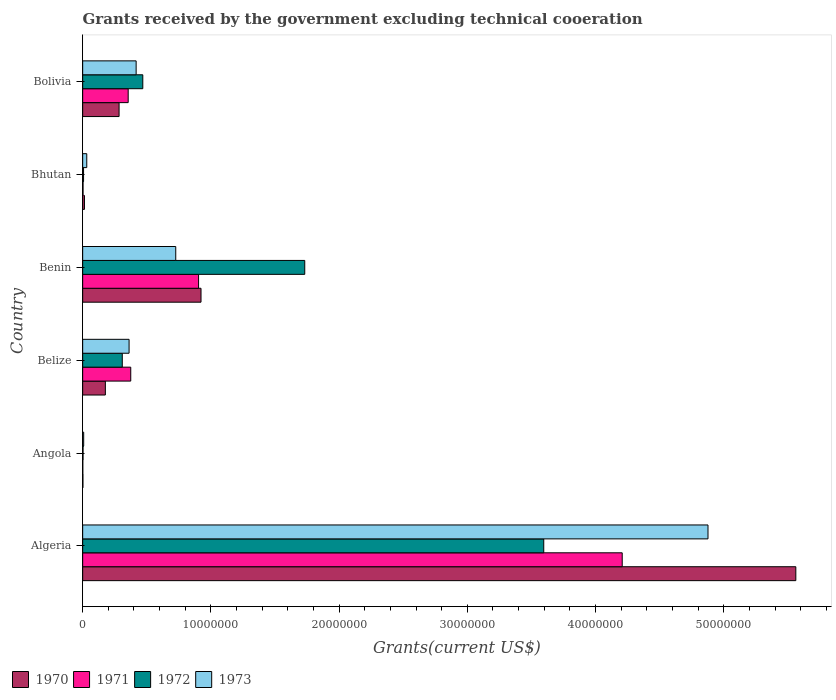How many groups of bars are there?
Your answer should be compact. 6. Are the number of bars per tick equal to the number of legend labels?
Your answer should be very brief. Yes. How many bars are there on the 4th tick from the top?
Provide a short and direct response. 4. What is the label of the 3rd group of bars from the top?
Your response must be concise. Benin. In how many cases, is the number of bars for a given country not equal to the number of legend labels?
Offer a terse response. 0. What is the total grants received by the government in 1972 in Benin?
Provide a short and direct response. 1.73e+07. Across all countries, what is the maximum total grants received by the government in 1971?
Your response must be concise. 4.21e+07. In which country was the total grants received by the government in 1973 maximum?
Provide a short and direct response. Algeria. In which country was the total grants received by the government in 1971 minimum?
Provide a short and direct response. Angola. What is the total total grants received by the government in 1971 in the graph?
Offer a very short reply. 5.85e+07. What is the difference between the total grants received by the government in 1972 in Algeria and that in Angola?
Ensure brevity in your answer.  3.59e+07. What is the average total grants received by the government in 1970 per country?
Your response must be concise. 1.16e+07. What is the difference between the total grants received by the government in 1973 and total grants received by the government in 1971 in Bolivia?
Keep it short and to the point. 6.20e+05. In how many countries, is the total grants received by the government in 1972 greater than 28000000 US$?
Provide a succinct answer. 1. What is the ratio of the total grants received by the government in 1972 in Angola to that in Bhutan?
Offer a terse response. 0.43. Is the total grants received by the government in 1972 in Algeria less than that in Belize?
Your answer should be very brief. No. What is the difference between the highest and the second highest total grants received by the government in 1971?
Ensure brevity in your answer.  3.30e+07. What is the difference between the highest and the lowest total grants received by the government in 1972?
Keep it short and to the point. 3.59e+07. In how many countries, is the total grants received by the government in 1973 greater than the average total grants received by the government in 1973 taken over all countries?
Provide a short and direct response. 1. Is the sum of the total grants received by the government in 1972 in Benin and Bhutan greater than the maximum total grants received by the government in 1971 across all countries?
Give a very brief answer. No. Is it the case that in every country, the sum of the total grants received by the government in 1970 and total grants received by the government in 1971 is greater than the sum of total grants received by the government in 1972 and total grants received by the government in 1973?
Provide a succinct answer. No. What does the 4th bar from the top in Algeria represents?
Your answer should be very brief. 1970. What does the 4th bar from the bottom in Algeria represents?
Make the answer very short. 1973. Is it the case that in every country, the sum of the total grants received by the government in 1971 and total grants received by the government in 1970 is greater than the total grants received by the government in 1973?
Provide a succinct answer. No. How many countries are there in the graph?
Provide a short and direct response. 6. How many legend labels are there?
Give a very brief answer. 4. What is the title of the graph?
Offer a very short reply. Grants received by the government excluding technical cooeration. What is the label or title of the X-axis?
Keep it short and to the point. Grants(current US$). What is the label or title of the Y-axis?
Offer a terse response. Country. What is the Grants(current US$) in 1970 in Algeria?
Ensure brevity in your answer.  5.56e+07. What is the Grants(current US$) of 1971 in Algeria?
Your response must be concise. 4.21e+07. What is the Grants(current US$) in 1972 in Algeria?
Your answer should be very brief. 3.60e+07. What is the Grants(current US$) in 1973 in Algeria?
Offer a very short reply. 4.88e+07. What is the Grants(current US$) in 1970 in Angola?
Your response must be concise. 2.00e+04. What is the Grants(current US$) in 1973 in Angola?
Give a very brief answer. 8.00e+04. What is the Grants(current US$) of 1970 in Belize?
Give a very brief answer. 1.77e+06. What is the Grants(current US$) of 1971 in Belize?
Offer a terse response. 3.75e+06. What is the Grants(current US$) in 1972 in Belize?
Keep it short and to the point. 3.09e+06. What is the Grants(current US$) in 1973 in Belize?
Offer a terse response. 3.62e+06. What is the Grants(current US$) of 1970 in Benin?
Provide a short and direct response. 9.23e+06. What is the Grants(current US$) of 1971 in Benin?
Your response must be concise. 9.04e+06. What is the Grants(current US$) in 1972 in Benin?
Provide a short and direct response. 1.73e+07. What is the Grants(current US$) of 1973 in Benin?
Your answer should be compact. 7.26e+06. What is the Grants(current US$) in 1970 in Bolivia?
Provide a short and direct response. 2.84e+06. What is the Grants(current US$) of 1971 in Bolivia?
Provide a short and direct response. 3.55e+06. What is the Grants(current US$) in 1972 in Bolivia?
Provide a succinct answer. 4.69e+06. What is the Grants(current US$) of 1973 in Bolivia?
Ensure brevity in your answer.  4.17e+06. Across all countries, what is the maximum Grants(current US$) of 1970?
Make the answer very short. 5.56e+07. Across all countries, what is the maximum Grants(current US$) of 1971?
Your answer should be very brief. 4.21e+07. Across all countries, what is the maximum Grants(current US$) of 1972?
Your answer should be compact. 3.60e+07. Across all countries, what is the maximum Grants(current US$) of 1973?
Provide a succinct answer. 4.88e+07. Across all countries, what is the minimum Grants(current US$) of 1970?
Keep it short and to the point. 2.00e+04. What is the total Grants(current US$) in 1970 in the graph?
Your answer should be very brief. 6.96e+07. What is the total Grants(current US$) of 1971 in the graph?
Ensure brevity in your answer.  5.85e+07. What is the total Grants(current US$) of 1972 in the graph?
Provide a short and direct response. 6.12e+07. What is the total Grants(current US$) in 1973 in the graph?
Provide a short and direct response. 6.42e+07. What is the difference between the Grants(current US$) of 1970 in Algeria and that in Angola?
Provide a succinct answer. 5.56e+07. What is the difference between the Grants(current US$) of 1971 in Algeria and that in Angola?
Offer a terse response. 4.21e+07. What is the difference between the Grants(current US$) of 1972 in Algeria and that in Angola?
Ensure brevity in your answer.  3.59e+07. What is the difference between the Grants(current US$) of 1973 in Algeria and that in Angola?
Offer a very short reply. 4.87e+07. What is the difference between the Grants(current US$) in 1970 in Algeria and that in Belize?
Provide a succinct answer. 5.38e+07. What is the difference between the Grants(current US$) of 1971 in Algeria and that in Belize?
Provide a succinct answer. 3.83e+07. What is the difference between the Grants(current US$) in 1972 in Algeria and that in Belize?
Ensure brevity in your answer.  3.29e+07. What is the difference between the Grants(current US$) of 1973 in Algeria and that in Belize?
Keep it short and to the point. 4.52e+07. What is the difference between the Grants(current US$) of 1970 in Algeria and that in Benin?
Keep it short and to the point. 4.64e+07. What is the difference between the Grants(current US$) of 1971 in Algeria and that in Benin?
Your answer should be very brief. 3.30e+07. What is the difference between the Grants(current US$) in 1972 in Algeria and that in Benin?
Make the answer very short. 1.86e+07. What is the difference between the Grants(current US$) of 1973 in Algeria and that in Benin?
Ensure brevity in your answer.  4.15e+07. What is the difference between the Grants(current US$) of 1970 in Algeria and that in Bhutan?
Give a very brief answer. 5.55e+07. What is the difference between the Grants(current US$) in 1971 in Algeria and that in Bhutan?
Provide a short and direct response. 4.20e+07. What is the difference between the Grants(current US$) of 1972 in Algeria and that in Bhutan?
Keep it short and to the point. 3.59e+07. What is the difference between the Grants(current US$) in 1973 in Algeria and that in Bhutan?
Your response must be concise. 4.84e+07. What is the difference between the Grants(current US$) of 1970 in Algeria and that in Bolivia?
Provide a short and direct response. 5.28e+07. What is the difference between the Grants(current US$) of 1971 in Algeria and that in Bolivia?
Provide a succinct answer. 3.85e+07. What is the difference between the Grants(current US$) in 1972 in Algeria and that in Bolivia?
Your answer should be very brief. 3.13e+07. What is the difference between the Grants(current US$) in 1973 in Algeria and that in Bolivia?
Keep it short and to the point. 4.46e+07. What is the difference between the Grants(current US$) of 1970 in Angola and that in Belize?
Offer a terse response. -1.75e+06. What is the difference between the Grants(current US$) of 1971 in Angola and that in Belize?
Provide a short and direct response. -3.74e+06. What is the difference between the Grants(current US$) in 1972 in Angola and that in Belize?
Make the answer very short. -3.06e+06. What is the difference between the Grants(current US$) in 1973 in Angola and that in Belize?
Offer a terse response. -3.54e+06. What is the difference between the Grants(current US$) of 1970 in Angola and that in Benin?
Your answer should be compact. -9.21e+06. What is the difference between the Grants(current US$) of 1971 in Angola and that in Benin?
Keep it short and to the point. -9.03e+06. What is the difference between the Grants(current US$) in 1972 in Angola and that in Benin?
Keep it short and to the point. -1.73e+07. What is the difference between the Grants(current US$) of 1973 in Angola and that in Benin?
Offer a very short reply. -7.18e+06. What is the difference between the Grants(current US$) of 1971 in Angola and that in Bhutan?
Your response must be concise. -2.00e+04. What is the difference between the Grants(current US$) in 1973 in Angola and that in Bhutan?
Offer a very short reply. -2.40e+05. What is the difference between the Grants(current US$) of 1970 in Angola and that in Bolivia?
Give a very brief answer. -2.82e+06. What is the difference between the Grants(current US$) of 1971 in Angola and that in Bolivia?
Offer a terse response. -3.54e+06. What is the difference between the Grants(current US$) in 1972 in Angola and that in Bolivia?
Keep it short and to the point. -4.66e+06. What is the difference between the Grants(current US$) in 1973 in Angola and that in Bolivia?
Provide a succinct answer. -4.09e+06. What is the difference between the Grants(current US$) of 1970 in Belize and that in Benin?
Ensure brevity in your answer.  -7.46e+06. What is the difference between the Grants(current US$) of 1971 in Belize and that in Benin?
Your response must be concise. -5.29e+06. What is the difference between the Grants(current US$) in 1972 in Belize and that in Benin?
Ensure brevity in your answer.  -1.42e+07. What is the difference between the Grants(current US$) in 1973 in Belize and that in Benin?
Provide a short and direct response. -3.64e+06. What is the difference between the Grants(current US$) of 1970 in Belize and that in Bhutan?
Give a very brief answer. 1.63e+06. What is the difference between the Grants(current US$) of 1971 in Belize and that in Bhutan?
Make the answer very short. 3.72e+06. What is the difference between the Grants(current US$) in 1972 in Belize and that in Bhutan?
Provide a short and direct response. 3.02e+06. What is the difference between the Grants(current US$) in 1973 in Belize and that in Bhutan?
Provide a short and direct response. 3.30e+06. What is the difference between the Grants(current US$) of 1970 in Belize and that in Bolivia?
Keep it short and to the point. -1.07e+06. What is the difference between the Grants(current US$) of 1972 in Belize and that in Bolivia?
Offer a terse response. -1.60e+06. What is the difference between the Grants(current US$) of 1973 in Belize and that in Bolivia?
Make the answer very short. -5.50e+05. What is the difference between the Grants(current US$) in 1970 in Benin and that in Bhutan?
Offer a terse response. 9.09e+06. What is the difference between the Grants(current US$) in 1971 in Benin and that in Bhutan?
Give a very brief answer. 9.01e+06. What is the difference between the Grants(current US$) of 1972 in Benin and that in Bhutan?
Ensure brevity in your answer.  1.72e+07. What is the difference between the Grants(current US$) of 1973 in Benin and that in Bhutan?
Your answer should be very brief. 6.94e+06. What is the difference between the Grants(current US$) of 1970 in Benin and that in Bolivia?
Provide a short and direct response. 6.39e+06. What is the difference between the Grants(current US$) of 1971 in Benin and that in Bolivia?
Provide a succinct answer. 5.49e+06. What is the difference between the Grants(current US$) in 1972 in Benin and that in Bolivia?
Offer a terse response. 1.26e+07. What is the difference between the Grants(current US$) of 1973 in Benin and that in Bolivia?
Provide a short and direct response. 3.09e+06. What is the difference between the Grants(current US$) of 1970 in Bhutan and that in Bolivia?
Your answer should be very brief. -2.70e+06. What is the difference between the Grants(current US$) in 1971 in Bhutan and that in Bolivia?
Ensure brevity in your answer.  -3.52e+06. What is the difference between the Grants(current US$) in 1972 in Bhutan and that in Bolivia?
Give a very brief answer. -4.62e+06. What is the difference between the Grants(current US$) of 1973 in Bhutan and that in Bolivia?
Provide a succinct answer. -3.85e+06. What is the difference between the Grants(current US$) of 1970 in Algeria and the Grants(current US$) of 1971 in Angola?
Provide a short and direct response. 5.56e+07. What is the difference between the Grants(current US$) in 1970 in Algeria and the Grants(current US$) in 1972 in Angola?
Your answer should be very brief. 5.56e+07. What is the difference between the Grants(current US$) of 1970 in Algeria and the Grants(current US$) of 1973 in Angola?
Offer a terse response. 5.55e+07. What is the difference between the Grants(current US$) in 1971 in Algeria and the Grants(current US$) in 1972 in Angola?
Provide a short and direct response. 4.20e+07. What is the difference between the Grants(current US$) in 1971 in Algeria and the Grants(current US$) in 1973 in Angola?
Give a very brief answer. 4.20e+07. What is the difference between the Grants(current US$) in 1972 in Algeria and the Grants(current US$) in 1973 in Angola?
Provide a short and direct response. 3.59e+07. What is the difference between the Grants(current US$) in 1970 in Algeria and the Grants(current US$) in 1971 in Belize?
Offer a very short reply. 5.19e+07. What is the difference between the Grants(current US$) of 1970 in Algeria and the Grants(current US$) of 1972 in Belize?
Keep it short and to the point. 5.25e+07. What is the difference between the Grants(current US$) in 1970 in Algeria and the Grants(current US$) in 1973 in Belize?
Keep it short and to the point. 5.20e+07. What is the difference between the Grants(current US$) of 1971 in Algeria and the Grants(current US$) of 1972 in Belize?
Ensure brevity in your answer.  3.90e+07. What is the difference between the Grants(current US$) in 1971 in Algeria and the Grants(current US$) in 1973 in Belize?
Your answer should be very brief. 3.85e+07. What is the difference between the Grants(current US$) of 1972 in Algeria and the Grants(current US$) of 1973 in Belize?
Keep it short and to the point. 3.23e+07. What is the difference between the Grants(current US$) in 1970 in Algeria and the Grants(current US$) in 1971 in Benin?
Ensure brevity in your answer.  4.66e+07. What is the difference between the Grants(current US$) of 1970 in Algeria and the Grants(current US$) of 1972 in Benin?
Keep it short and to the point. 3.83e+07. What is the difference between the Grants(current US$) of 1970 in Algeria and the Grants(current US$) of 1973 in Benin?
Provide a short and direct response. 4.84e+07. What is the difference between the Grants(current US$) in 1971 in Algeria and the Grants(current US$) in 1972 in Benin?
Make the answer very short. 2.48e+07. What is the difference between the Grants(current US$) of 1971 in Algeria and the Grants(current US$) of 1973 in Benin?
Ensure brevity in your answer.  3.48e+07. What is the difference between the Grants(current US$) in 1972 in Algeria and the Grants(current US$) in 1973 in Benin?
Give a very brief answer. 2.87e+07. What is the difference between the Grants(current US$) of 1970 in Algeria and the Grants(current US$) of 1971 in Bhutan?
Your answer should be very brief. 5.56e+07. What is the difference between the Grants(current US$) of 1970 in Algeria and the Grants(current US$) of 1972 in Bhutan?
Your answer should be very brief. 5.56e+07. What is the difference between the Grants(current US$) in 1970 in Algeria and the Grants(current US$) in 1973 in Bhutan?
Make the answer very short. 5.53e+07. What is the difference between the Grants(current US$) in 1971 in Algeria and the Grants(current US$) in 1972 in Bhutan?
Provide a short and direct response. 4.20e+07. What is the difference between the Grants(current US$) in 1971 in Algeria and the Grants(current US$) in 1973 in Bhutan?
Offer a very short reply. 4.18e+07. What is the difference between the Grants(current US$) of 1972 in Algeria and the Grants(current US$) of 1973 in Bhutan?
Offer a very short reply. 3.56e+07. What is the difference between the Grants(current US$) of 1970 in Algeria and the Grants(current US$) of 1971 in Bolivia?
Make the answer very short. 5.21e+07. What is the difference between the Grants(current US$) in 1970 in Algeria and the Grants(current US$) in 1972 in Bolivia?
Your response must be concise. 5.09e+07. What is the difference between the Grants(current US$) of 1970 in Algeria and the Grants(current US$) of 1973 in Bolivia?
Provide a succinct answer. 5.14e+07. What is the difference between the Grants(current US$) in 1971 in Algeria and the Grants(current US$) in 1972 in Bolivia?
Your answer should be compact. 3.74e+07. What is the difference between the Grants(current US$) of 1971 in Algeria and the Grants(current US$) of 1973 in Bolivia?
Your answer should be compact. 3.79e+07. What is the difference between the Grants(current US$) of 1972 in Algeria and the Grants(current US$) of 1973 in Bolivia?
Make the answer very short. 3.18e+07. What is the difference between the Grants(current US$) in 1970 in Angola and the Grants(current US$) in 1971 in Belize?
Make the answer very short. -3.73e+06. What is the difference between the Grants(current US$) of 1970 in Angola and the Grants(current US$) of 1972 in Belize?
Offer a very short reply. -3.07e+06. What is the difference between the Grants(current US$) in 1970 in Angola and the Grants(current US$) in 1973 in Belize?
Provide a short and direct response. -3.60e+06. What is the difference between the Grants(current US$) of 1971 in Angola and the Grants(current US$) of 1972 in Belize?
Your answer should be very brief. -3.08e+06. What is the difference between the Grants(current US$) in 1971 in Angola and the Grants(current US$) in 1973 in Belize?
Your answer should be very brief. -3.61e+06. What is the difference between the Grants(current US$) of 1972 in Angola and the Grants(current US$) of 1973 in Belize?
Provide a succinct answer. -3.59e+06. What is the difference between the Grants(current US$) in 1970 in Angola and the Grants(current US$) in 1971 in Benin?
Ensure brevity in your answer.  -9.02e+06. What is the difference between the Grants(current US$) of 1970 in Angola and the Grants(current US$) of 1972 in Benin?
Your response must be concise. -1.73e+07. What is the difference between the Grants(current US$) of 1970 in Angola and the Grants(current US$) of 1973 in Benin?
Provide a short and direct response. -7.24e+06. What is the difference between the Grants(current US$) in 1971 in Angola and the Grants(current US$) in 1972 in Benin?
Ensure brevity in your answer.  -1.73e+07. What is the difference between the Grants(current US$) of 1971 in Angola and the Grants(current US$) of 1973 in Benin?
Ensure brevity in your answer.  -7.25e+06. What is the difference between the Grants(current US$) in 1972 in Angola and the Grants(current US$) in 1973 in Benin?
Give a very brief answer. -7.23e+06. What is the difference between the Grants(current US$) in 1970 in Angola and the Grants(current US$) in 1973 in Bhutan?
Your answer should be compact. -3.00e+05. What is the difference between the Grants(current US$) of 1971 in Angola and the Grants(current US$) of 1973 in Bhutan?
Make the answer very short. -3.10e+05. What is the difference between the Grants(current US$) in 1972 in Angola and the Grants(current US$) in 1973 in Bhutan?
Your answer should be compact. -2.90e+05. What is the difference between the Grants(current US$) of 1970 in Angola and the Grants(current US$) of 1971 in Bolivia?
Provide a succinct answer. -3.53e+06. What is the difference between the Grants(current US$) in 1970 in Angola and the Grants(current US$) in 1972 in Bolivia?
Your answer should be compact. -4.67e+06. What is the difference between the Grants(current US$) of 1970 in Angola and the Grants(current US$) of 1973 in Bolivia?
Provide a short and direct response. -4.15e+06. What is the difference between the Grants(current US$) in 1971 in Angola and the Grants(current US$) in 1972 in Bolivia?
Keep it short and to the point. -4.68e+06. What is the difference between the Grants(current US$) of 1971 in Angola and the Grants(current US$) of 1973 in Bolivia?
Make the answer very short. -4.16e+06. What is the difference between the Grants(current US$) of 1972 in Angola and the Grants(current US$) of 1973 in Bolivia?
Ensure brevity in your answer.  -4.14e+06. What is the difference between the Grants(current US$) in 1970 in Belize and the Grants(current US$) in 1971 in Benin?
Ensure brevity in your answer.  -7.27e+06. What is the difference between the Grants(current US$) of 1970 in Belize and the Grants(current US$) of 1972 in Benin?
Offer a very short reply. -1.56e+07. What is the difference between the Grants(current US$) in 1970 in Belize and the Grants(current US$) in 1973 in Benin?
Offer a terse response. -5.49e+06. What is the difference between the Grants(current US$) of 1971 in Belize and the Grants(current US$) of 1972 in Benin?
Provide a short and direct response. -1.36e+07. What is the difference between the Grants(current US$) of 1971 in Belize and the Grants(current US$) of 1973 in Benin?
Make the answer very short. -3.51e+06. What is the difference between the Grants(current US$) of 1972 in Belize and the Grants(current US$) of 1973 in Benin?
Give a very brief answer. -4.17e+06. What is the difference between the Grants(current US$) in 1970 in Belize and the Grants(current US$) in 1971 in Bhutan?
Ensure brevity in your answer.  1.74e+06. What is the difference between the Grants(current US$) of 1970 in Belize and the Grants(current US$) of 1972 in Bhutan?
Your answer should be compact. 1.70e+06. What is the difference between the Grants(current US$) of 1970 in Belize and the Grants(current US$) of 1973 in Bhutan?
Offer a terse response. 1.45e+06. What is the difference between the Grants(current US$) of 1971 in Belize and the Grants(current US$) of 1972 in Bhutan?
Keep it short and to the point. 3.68e+06. What is the difference between the Grants(current US$) in 1971 in Belize and the Grants(current US$) in 1973 in Bhutan?
Make the answer very short. 3.43e+06. What is the difference between the Grants(current US$) in 1972 in Belize and the Grants(current US$) in 1973 in Bhutan?
Your answer should be very brief. 2.77e+06. What is the difference between the Grants(current US$) of 1970 in Belize and the Grants(current US$) of 1971 in Bolivia?
Your answer should be compact. -1.78e+06. What is the difference between the Grants(current US$) in 1970 in Belize and the Grants(current US$) in 1972 in Bolivia?
Give a very brief answer. -2.92e+06. What is the difference between the Grants(current US$) in 1970 in Belize and the Grants(current US$) in 1973 in Bolivia?
Provide a succinct answer. -2.40e+06. What is the difference between the Grants(current US$) of 1971 in Belize and the Grants(current US$) of 1972 in Bolivia?
Offer a terse response. -9.40e+05. What is the difference between the Grants(current US$) in 1971 in Belize and the Grants(current US$) in 1973 in Bolivia?
Provide a short and direct response. -4.20e+05. What is the difference between the Grants(current US$) of 1972 in Belize and the Grants(current US$) of 1973 in Bolivia?
Ensure brevity in your answer.  -1.08e+06. What is the difference between the Grants(current US$) of 1970 in Benin and the Grants(current US$) of 1971 in Bhutan?
Your answer should be very brief. 9.20e+06. What is the difference between the Grants(current US$) of 1970 in Benin and the Grants(current US$) of 1972 in Bhutan?
Your response must be concise. 9.16e+06. What is the difference between the Grants(current US$) in 1970 in Benin and the Grants(current US$) in 1973 in Bhutan?
Keep it short and to the point. 8.91e+06. What is the difference between the Grants(current US$) in 1971 in Benin and the Grants(current US$) in 1972 in Bhutan?
Your response must be concise. 8.97e+06. What is the difference between the Grants(current US$) in 1971 in Benin and the Grants(current US$) in 1973 in Bhutan?
Provide a short and direct response. 8.72e+06. What is the difference between the Grants(current US$) of 1972 in Benin and the Grants(current US$) of 1973 in Bhutan?
Provide a succinct answer. 1.70e+07. What is the difference between the Grants(current US$) of 1970 in Benin and the Grants(current US$) of 1971 in Bolivia?
Provide a succinct answer. 5.68e+06. What is the difference between the Grants(current US$) in 1970 in Benin and the Grants(current US$) in 1972 in Bolivia?
Give a very brief answer. 4.54e+06. What is the difference between the Grants(current US$) of 1970 in Benin and the Grants(current US$) of 1973 in Bolivia?
Offer a terse response. 5.06e+06. What is the difference between the Grants(current US$) of 1971 in Benin and the Grants(current US$) of 1972 in Bolivia?
Ensure brevity in your answer.  4.35e+06. What is the difference between the Grants(current US$) of 1971 in Benin and the Grants(current US$) of 1973 in Bolivia?
Your answer should be very brief. 4.87e+06. What is the difference between the Grants(current US$) of 1972 in Benin and the Grants(current US$) of 1973 in Bolivia?
Offer a terse response. 1.32e+07. What is the difference between the Grants(current US$) in 1970 in Bhutan and the Grants(current US$) in 1971 in Bolivia?
Your answer should be compact. -3.41e+06. What is the difference between the Grants(current US$) of 1970 in Bhutan and the Grants(current US$) of 1972 in Bolivia?
Give a very brief answer. -4.55e+06. What is the difference between the Grants(current US$) of 1970 in Bhutan and the Grants(current US$) of 1973 in Bolivia?
Your answer should be very brief. -4.03e+06. What is the difference between the Grants(current US$) in 1971 in Bhutan and the Grants(current US$) in 1972 in Bolivia?
Your response must be concise. -4.66e+06. What is the difference between the Grants(current US$) of 1971 in Bhutan and the Grants(current US$) of 1973 in Bolivia?
Your answer should be very brief. -4.14e+06. What is the difference between the Grants(current US$) in 1972 in Bhutan and the Grants(current US$) in 1973 in Bolivia?
Make the answer very short. -4.10e+06. What is the average Grants(current US$) of 1970 per country?
Ensure brevity in your answer.  1.16e+07. What is the average Grants(current US$) of 1971 per country?
Make the answer very short. 9.74e+06. What is the average Grants(current US$) of 1972 per country?
Make the answer very short. 1.02e+07. What is the average Grants(current US$) in 1973 per country?
Offer a very short reply. 1.07e+07. What is the difference between the Grants(current US$) of 1970 and Grants(current US$) of 1971 in Algeria?
Offer a very short reply. 1.35e+07. What is the difference between the Grants(current US$) in 1970 and Grants(current US$) in 1972 in Algeria?
Provide a short and direct response. 1.97e+07. What is the difference between the Grants(current US$) in 1970 and Grants(current US$) in 1973 in Algeria?
Your answer should be compact. 6.85e+06. What is the difference between the Grants(current US$) in 1971 and Grants(current US$) in 1972 in Algeria?
Your response must be concise. 6.12e+06. What is the difference between the Grants(current US$) of 1971 and Grants(current US$) of 1973 in Algeria?
Your response must be concise. -6.69e+06. What is the difference between the Grants(current US$) of 1972 and Grants(current US$) of 1973 in Algeria?
Give a very brief answer. -1.28e+07. What is the difference between the Grants(current US$) in 1970 and Grants(current US$) in 1971 in Angola?
Your answer should be compact. 10000. What is the difference between the Grants(current US$) in 1970 and Grants(current US$) in 1973 in Angola?
Make the answer very short. -6.00e+04. What is the difference between the Grants(current US$) of 1971 and Grants(current US$) of 1972 in Angola?
Provide a short and direct response. -2.00e+04. What is the difference between the Grants(current US$) in 1972 and Grants(current US$) in 1973 in Angola?
Keep it short and to the point. -5.00e+04. What is the difference between the Grants(current US$) of 1970 and Grants(current US$) of 1971 in Belize?
Ensure brevity in your answer.  -1.98e+06. What is the difference between the Grants(current US$) in 1970 and Grants(current US$) in 1972 in Belize?
Ensure brevity in your answer.  -1.32e+06. What is the difference between the Grants(current US$) of 1970 and Grants(current US$) of 1973 in Belize?
Your answer should be compact. -1.85e+06. What is the difference between the Grants(current US$) in 1972 and Grants(current US$) in 1973 in Belize?
Give a very brief answer. -5.30e+05. What is the difference between the Grants(current US$) of 1970 and Grants(current US$) of 1972 in Benin?
Keep it short and to the point. -8.09e+06. What is the difference between the Grants(current US$) in 1970 and Grants(current US$) in 1973 in Benin?
Give a very brief answer. 1.97e+06. What is the difference between the Grants(current US$) in 1971 and Grants(current US$) in 1972 in Benin?
Provide a short and direct response. -8.28e+06. What is the difference between the Grants(current US$) in 1971 and Grants(current US$) in 1973 in Benin?
Offer a very short reply. 1.78e+06. What is the difference between the Grants(current US$) of 1972 and Grants(current US$) of 1973 in Benin?
Offer a terse response. 1.01e+07. What is the difference between the Grants(current US$) in 1970 and Grants(current US$) in 1971 in Bhutan?
Your answer should be compact. 1.10e+05. What is the difference between the Grants(current US$) of 1971 and Grants(current US$) of 1973 in Bhutan?
Your response must be concise. -2.90e+05. What is the difference between the Grants(current US$) in 1972 and Grants(current US$) in 1973 in Bhutan?
Offer a terse response. -2.50e+05. What is the difference between the Grants(current US$) in 1970 and Grants(current US$) in 1971 in Bolivia?
Provide a short and direct response. -7.10e+05. What is the difference between the Grants(current US$) in 1970 and Grants(current US$) in 1972 in Bolivia?
Give a very brief answer. -1.85e+06. What is the difference between the Grants(current US$) of 1970 and Grants(current US$) of 1973 in Bolivia?
Give a very brief answer. -1.33e+06. What is the difference between the Grants(current US$) of 1971 and Grants(current US$) of 1972 in Bolivia?
Provide a short and direct response. -1.14e+06. What is the difference between the Grants(current US$) of 1971 and Grants(current US$) of 1973 in Bolivia?
Give a very brief answer. -6.20e+05. What is the difference between the Grants(current US$) in 1972 and Grants(current US$) in 1973 in Bolivia?
Your answer should be very brief. 5.20e+05. What is the ratio of the Grants(current US$) of 1970 in Algeria to that in Angola?
Ensure brevity in your answer.  2781. What is the ratio of the Grants(current US$) of 1971 in Algeria to that in Angola?
Give a very brief answer. 4208. What is the ratio of the Grants(current US$) in 1972 in Algeria to that in Angola?
Give a very brief answer. 1198.67. What is the ratio of the Grants(current US$) of 1973 in Algeria to that in Angola?
Provide a succinct answer. 609.62. What is the ratio of the Grants(current US$) in 1970 in Algeria to that in Belize?
Your answer should be very brief. 31.42. What is the ratio of the Grants(current US$) in 1971 in Algeria to that in Belize?
Make the answer very short. 11.22. What is the ratio of the Grants(current US$) of 1972 in Algeria to that in Belize?
Your answer should be very brief. 11.64. What is the ratio of the Grants(current US$) of 1973 in Algeria to that in Belize?
Provide a succinct answer. 13.47. What is the ratio of the Grants(current US$) of 1970 in Algeria to that in Benin?
Ensure brevity in your answer.  6.03. What is the ratio of the Grants(current US$) in 1971 in Algeria to that in Benin?
Your response must be concise. 4.65. What is the ratio of the Grants(current US$) of 1972 in Algeria to that in Benin?
Give a very brief answer. 2.08. What is the ratio of the Grants(current US$) in 1973 in Algeria to that in Benin?
Your answer should be very brief. 6.72. What is the ratio of the Grants(current US$) in 1970 in Algeria to that in Bhutan?
Your answer should be very brief. 397.29. What is the ratio of the Grants(current US$) of 1971 in Algeria to that in Bhutan?
Your answer should be very brief. 1402.67. What is the ratio of the Grants(current US$) of 1972 in Algeria to that in Bhutan?
Your answer should be very brief. 513.71. What is the ratio of the Grants(current US$) in 1973 in Algeria to that in Bhutan?
Your answer should be compact. 152.41. What is the ratio of the Grants(current US$) in 1970 in Algeria to that in Bolivia?
Offer a terse response. 19.58. What is the ratio of the Grants(current US$) in 1971 in Algeria to that in Bolivia?
Offer a very short reply. 11.85. What is the ratio of the Grants(current US$) in 1972 in Algeria to that in Bolivia?
Give a very brief answer. 7.67. What is the ratio of the Grants(current US$) in 1973 in Algeria to that in Bolivia?
Keep it short and to the point. 11.7. What is the ratio of the Grants(current US$) of 1970 in Angola to that in Belize?
Your answer should be very brief. 0.01. What is the ratio of the Grants(current US$) in 1971 in Angola to that in Belize?
Your answer should be very brief. 0. What is the ratio of the Grants(current US$) of 1972 in Angola to that in Belize?
Keep it short and to the point. 0.01. What is the ratio of the Grants(current US$) of 1973 in Angola to that in Belize?
Provide a short and direct response. 0.02. What is the ratio of the Grants(current US$) in 1970 in Angola to that in Benin?
Your answer should be very brief. 0. What is the ratio of the Grants(current US$) of 1971 in Angola to that in Benin?
Give a very brief answer. 0. What is the ratio of the Grants(current US$) in 1972 in Angola to that in Benin?
Offer a terse response. 0. What is the ratio of the Grants(current US$) of 1973 in Angola to that in Benin?
Offer a terse response. 0.01. What is the ratio of the Grants(current US$) in 1970 in Angola to that in Bhutan?
Make the answer very short. 0.14. What is the ratio of the Grants(current US$) of 1971 in Angola to that in Bhutan?
Give a very brief answer. 0.33. What is the ratio of the Grants(current US$) of 1972 in Angola to that in Bhutan?
Your response must be concise. 0.43. What is the ratio of the Grants(current US$) of 1970 in Angola to that in Bolivia?
Provide a short and direct response. 0.01. What is the ratio of the Grants(current US$) in 1971 in Angola to that in Bolivia?
Provide a short and direct response. 0. What is the ratio of the Grants(current US$) in 1972 in Angola to that in Bolivia?
Your response must be concise. 0.01. What is the ratio of the Grants(current US$) of 1973 in Angola to that in Bolivia?
Provide a short and direct response. 0.02. What is the ratio of the Grants(current US$) in 1970 in Belize to that in Benin?
Make the answer very short. 0.19. What is the ratio of the Grants(current US$) of 1971 in Belize to that in Benin?
Your response must be concise. 0.41. What is the ratio of the Grants(current US$) of 1972 in Belize to that in Benin?
Ensure brevity in your answer.  0.18. What is the ratio of the Grants(current US$) in 1973 in Belize to that in Benin?
Provide a succinct answer. 0.5. What is the ratio of the Grants(current US$) of 1970 in Belize to that in Bhutan?
Provide a succinct answer. 12.64. What is the ratio of the Grants(current US$) in 1971 in Belize to that in Bhutan?
Provide a short and direct response. 125. What is the ratio of the Grants(current US$) in 1972 in Belize to that in Bhutan?
Offer a very short reply. 44.14. What is the ratio of the Grants(current US$) of 1973 in Belize to that in Bhutan?
Your answer should be compact. 11.31. What is the ratio of the Grants(current US$) in 1970 in Belize to that in Bolivia?
Your answer should be very brief. 0.62. What is the ratio of the Grants(current US$) of 1971 in Belize to that in Bolivia?
Your answer should be compact. 1.06. What is the ratio of the Grants(current US$) of 1972 in Belize to that in Bolivia?
Your response must be concise. 0.66. What is the ratio of the Grants(current US$) of 1973 in Belize to that in Bolivia?
Offer a terse response. 0.87. What is the ratio of the Grants(current US$) in 1970 in Benin to that in Bhutan?
Make the answer very short. 65.93. What is the ratio of the Grants(current US$) of 1971 in Benin to that in Bhutan?
Your answer should be compact. 301.33. What is the ratio of the Grants(current US$) of 1972 in Benin to that in Bhutan?
Provide a short and direct response. 247.43. What is the ratio of the Grants(current US$) of 1973 in Benin to that in Bhutan?
Offer a terse response. 22.69. What is the ratio of the Grants(current US$) of 1970 in Benin to that in Bolivia?
Offer a very short reply. 3.25. What is the ratio of the Grants(current US$) of 1971 in Benin to that in Bolivia?
Provide a short and direct response. 2.55. What is the ratio of the Grants(current US$) in 1972 in Benin to that in Bolivia?
Ensure brevity in your answer.  3.69. What is the ratio of the Grants(current US$) of 1973 in Benin to that in Bolivia?
Offer a terse response. 1.74. What is the ratio of the Grants(current US$) of 1970 in Bhutan to that in Bolivia?
Your answer should be very brief. 0.05. What is the ratio of the Grants(current US$) in 1971 in Bhutan to that in Bolivia?
Make the answer very short. 0.01. What is the ratio of the Grants(current US$) in 1972 in Bhutan to that in Bolivia?
Offer a very short reply. 0.01. What is the ratio of the Grants(current US$) in 1973 in Bhutan to that in Bolivia?
Give a very brief answer. 0.08. What is the difference between the highest and the second highest Grants(current US$) of 1970?
Ensure brevity in your answer.  4.64e+07. What is the difference between the highest and the second highest Grants(current US$) of 1971?
Your answer should be very brief. 3.30e+07. What is the difference between the highest and the second highest Grants(current US$) in 1972?
Your answer should be compact. 1.86e+07. What is the difference between the highest and the second highest Grants(current US$) in 1973?
Your answer should be very brief. 4.15e+07. What is the difference between the highest and the lowest Grants(current US$) in 1970?
Offer a terse response. 5.56e+07. What is the difference between the highest and the lowest Grants(current US$) of 1971?
Your answer should be very brief. 4.21e+07. What is the difference between the highest and the lowest Grants(current US$) of 1972?
Provide a short and direct response. 3.59e+07. What is the difference between the highest and the lowest Grants(current US$) of 1973?
Provide a short and direct response. 4.87e+07. 